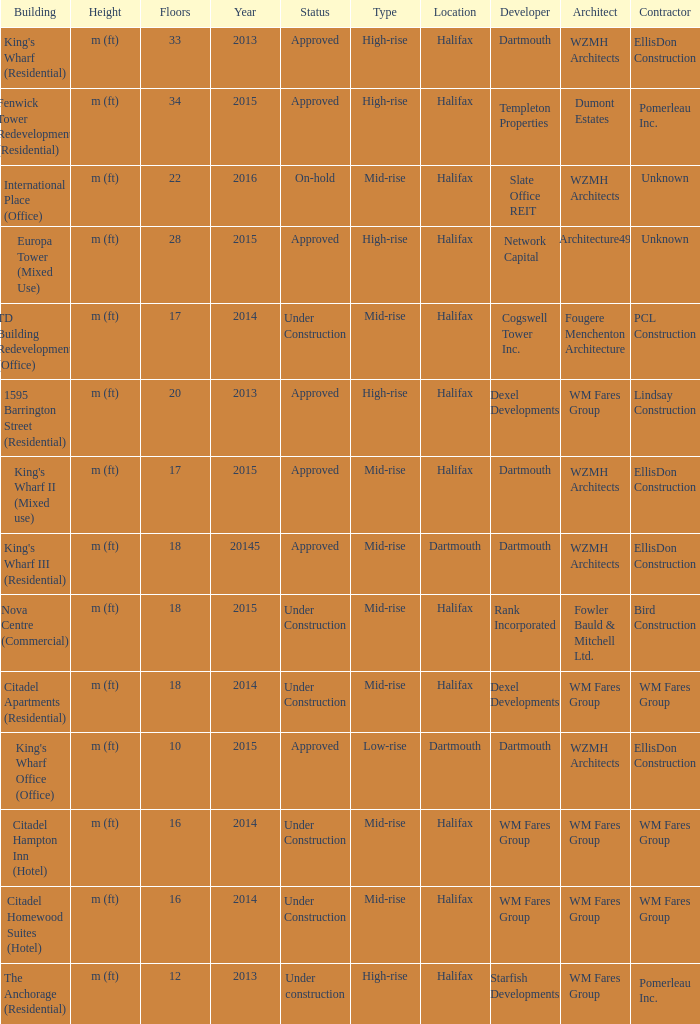What is the status of the building for 2014 with 33 floors? Approved. 